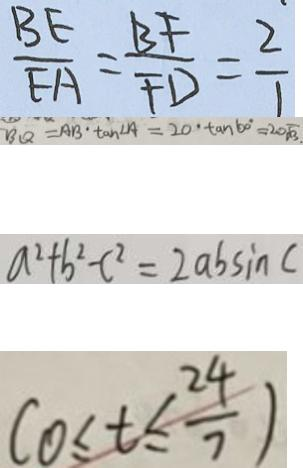Convert formula to latex. <formula><loc_0><loc_0><loc_500><loc_500>\frac { B E } { E A } = \frac { B F } { F D } = \frac { 2 } { 1 } 
 B Q = A B \cdot \tan \angle A = 2 0 \cdot \tan 6 0 ^ { \circ } = 2 0 \sqrt { 3 } . 
 a ^ { 2 } + b ^ { 2 } - c ^ { 2 } = 2 a b \sin c 
 ( 0 \leq t \leq \frac { 2 4 } { 7 } )</formula> 